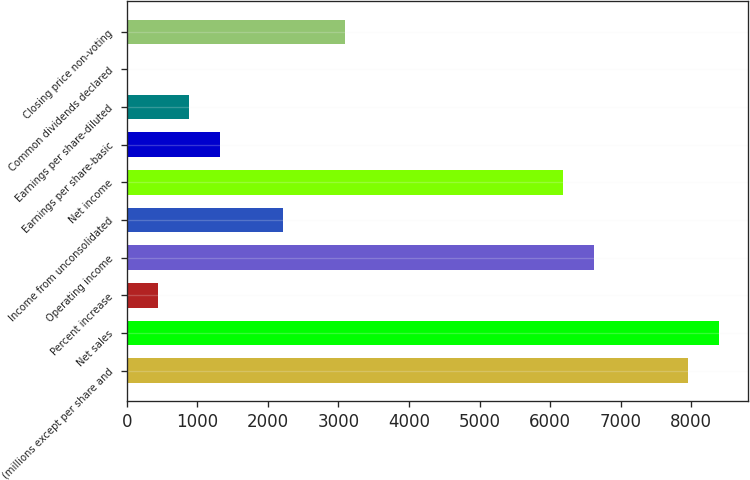<chart> <loc_0><loc_0><loc_500><loc_500><bar_chart><fcel>(millions except per share and<fcel>Net sales<fcel>Percent increase<fcel>Operating income<fcel>Income from unconsolidated<fcel>Net income<fcel>Earnings per share-basic<fcel>Earnings per share-diluted<fcel>Common dividends declared<fcel>Closing price non-voting<nl><fcel>7947.67<fcel>8389.13<fcel>442.85<fcel>6623.29<fcel>2208.69<fcel>6181.83<fcel>1325.77<fcel>884.31<fcel>1.39<fcel>3091.61<nl></chart> 